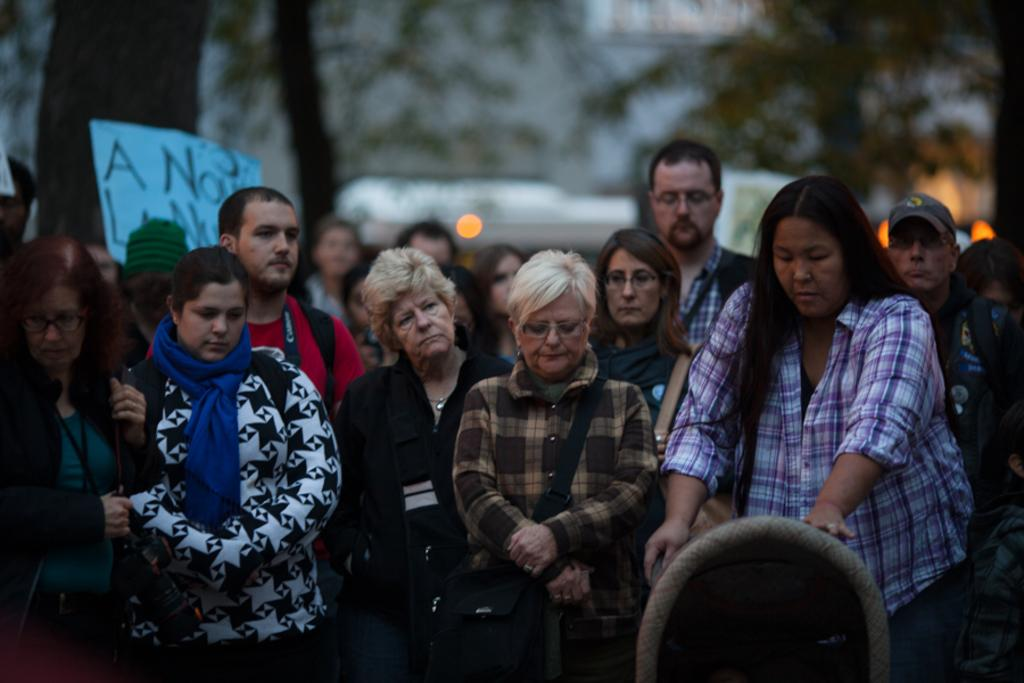What can be observed about the people in the image? There are people standing in the image. What are some people in the image wearing? Some people in the image are wearing bags. What type of natural environment is visible in the image? There are trees in the image. What type of man-made structure is visible in the image? There is a building in the image. What kind of sign or message is present in the image? There is a board with text in the image. What time of day is it in the image, and what is the mother doing? The time of day is not mentioned in the image, and there is no mother present in the image. Where is the drawer located in the image? There is no drawer present in the image. 